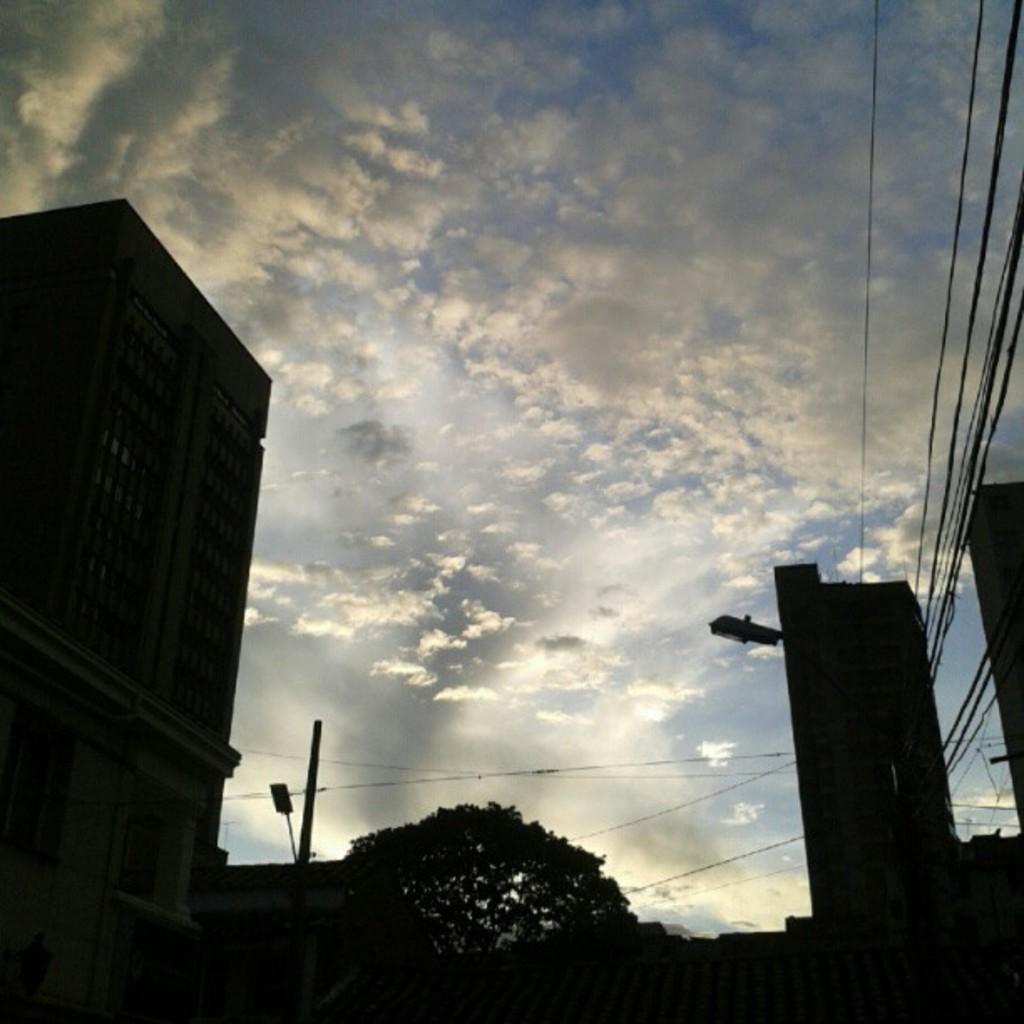Describe this image in one or two sentences. In this picture there are buildings, trees, poles and wires and the sky is cloudy. 